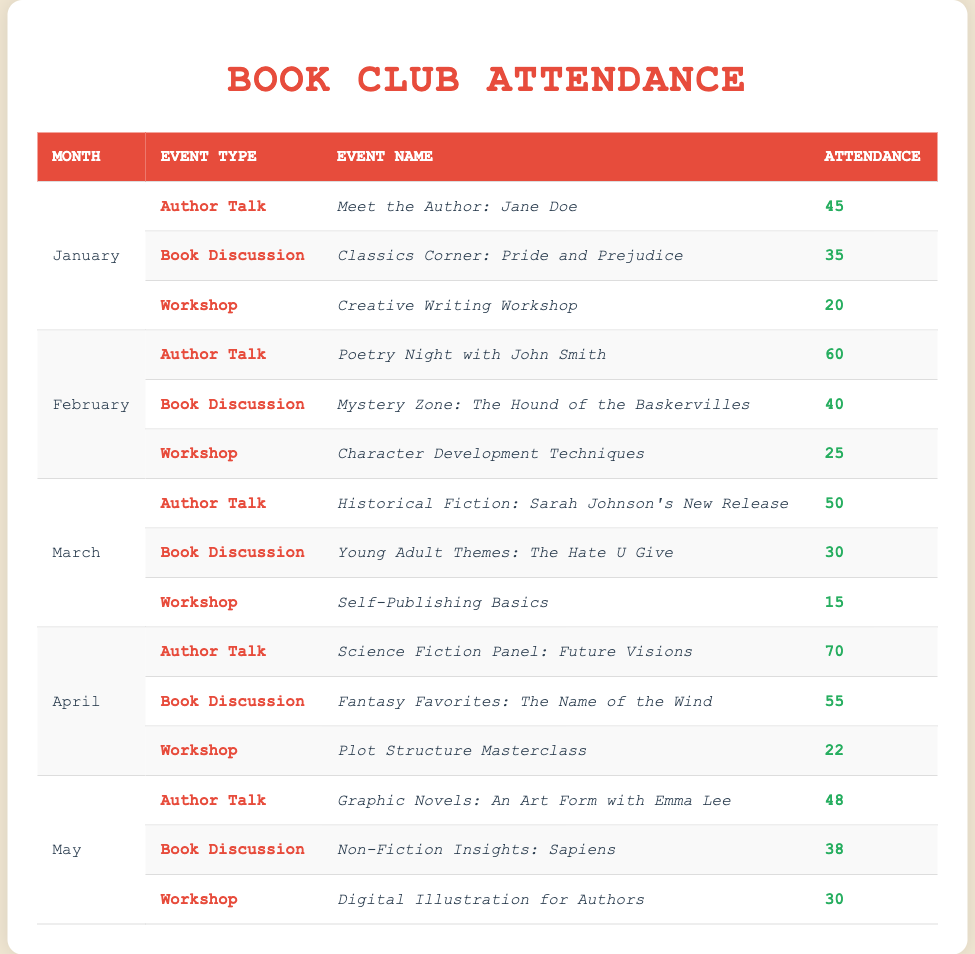What was the attendance for the workshop in February? The table shows that in February, the workshop event was "Character Development Techniques" with an attendance of 25.
Answer: 25 Which month had the highest attendance for an author talk? According to the table, April had the highest attendance for the author talk "Science Fiction Panel: Future Visions" with 70 attendees.
Answer: April How many attendees were there for book discussions across all months? To find the total attendees for book discussions, sum the attendance values for book discussions from all months: 35 (January) + 40 (February) + 30 (March) + 55 (April) + 38 (May) = 198.
Answer: 198 Was the attendance for the workshop in March greater than that in January? In March, the workshop attendance was 15, and in January, it was 20. Since 15 is less than 20, the statement is false.
Answer: No Which event type had the least attendance in May? The table indicates that the workshop "Digital Illustration for Authors" in May had the least attendance with 30 compared to the author talk and book discussion.
Answer: Workshop What is the average attendance for author talks across all months? The attendance for author talks are 45 (January) + 60 (February) + 50 (March) + 70 (April) + 48 (May) = 273. There are 5 author talks, so the average is 273/5 = 54.6, rounding to the nearest whole number gives 55.
Answer: 55 Which month had the lowest overall attendance? To assess the overall attendance for each month: January (45 + 35 + 20 = 100), February (60 + 40 + 25 = 125), March (50 + 30 + 15 = 95), April (70 + 55 + 22 = 147), May (48 + 38 + 30 = 116). The lowest total is March with 95.
Answer: March How many attendees participated in the event "Graphic Novels: An Art Form with Emma Lee"? The table shows that the attendance for the event "Graphic Novels: An Art Form with Emma Lee" in May was 48.
Answer: 48 Did the attendance for book discussions increase each month? The attendance for book discussions was: 35 (January), 40 (February), 30 (March), 55 (April), and 38 (May). Since March's 30 is lower than February's 40, the attendance did not increase each month.
Answer: No What was the total attendance for all types of events in April? The total attendance in April is the sum of all events: 70 (author talk) + 55 (book discussion) + 22 (workshop) = 147.
Answer: 147 